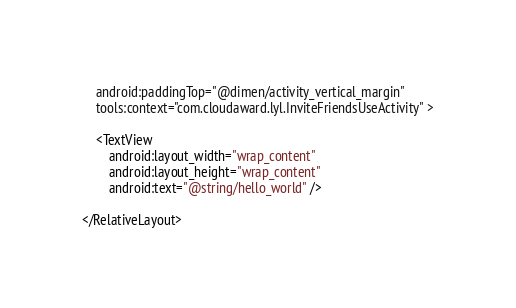<code> <loc_0><loc_0><loc_500><loc_500><_XML_>    android:paddingTop="@dimen/activity_vertical_margin"
    tools:context="com.cloudaward.lyl.InviteFriendsUseActivity" >

    <TextView
        android:layout_width="wrap_content"
        android:layout_height="wrap_content"
        android:text="@string/hello_world" />

</RelativeLayout>
</code> 